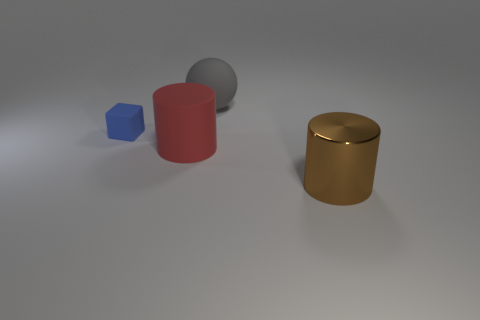Is there anything else that has the same material as the brown thing?
Make the answer very short. No. What is the material of the brown thing that is the same size as the gray rubber sphere?
Your answer should be very brief. Metal. There is a rubber thing that is in front of the big gray matte object and to the right of the tiny rubber thing; what shape is it?
Offer a terse response. Cylinder. How many things are either objects that are on the right side of the blue rubber cube or brown things?
Keep it short and to the point. 3. Are there any other things that are the same size as the brown object?
Give a very brief answer. Yes. There is a cylinder right of the big rubber object that is to the left of the large gray rubber sphere; what size is it?
Your response must be concise. Large. How many things are tiny gray metal objects or large cylinders that are behind the large brown object?
Your answer should be compact. 1. Does the big matte object in front of the block have the same shape as the brown shiny object?
Your response must be concise. Yes. There is a big object that is in front of the cylinder that is to the left of the large brown object; what number of small blue blocks are left of it?
Offer a terse response. 1. Is there anything else that is the same shape as the big red rubber thing?
Offer a terse response. Yes. 